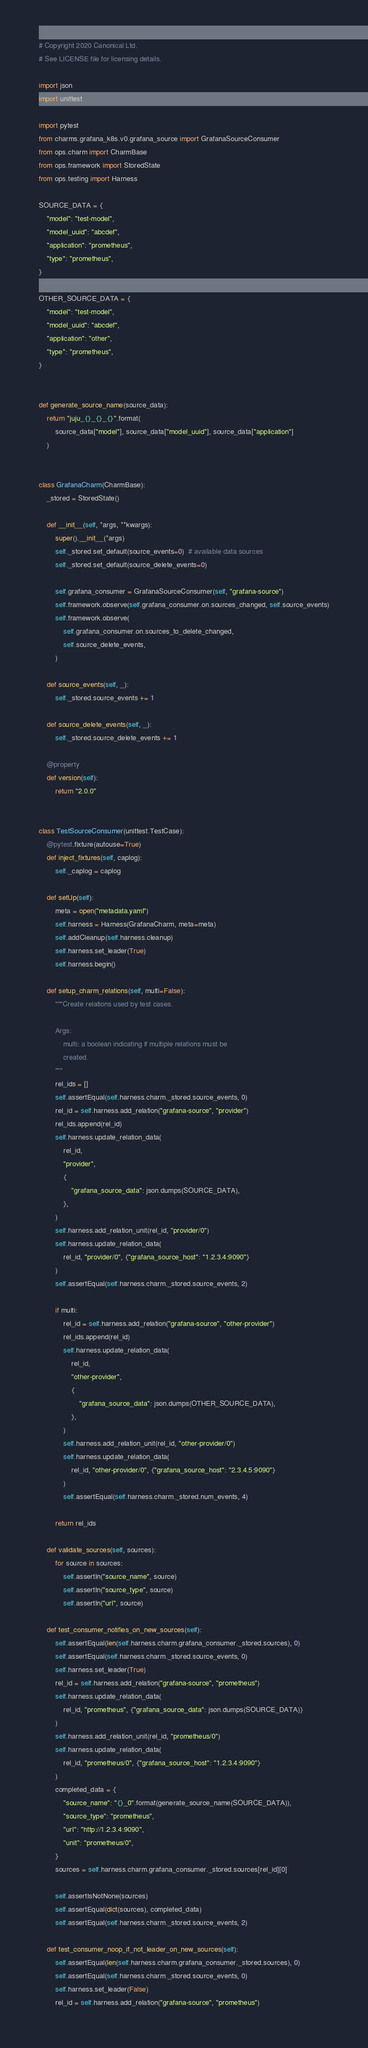<code> <loc_0><loc_0><loc_500><loc_500><_Python_># Copyright 2020 Canonical Ltd.
# See LICENSE file for licensing details.

import json
import unittest

import pytest
from charms.grafana_k8s.v0.grafana_source import GrafanaSourceConsumer
from ops.charm import CharmBase
from ops.framework import StoredState
from ops.testing import Harness

SOURCE_DATA = {
    "model": "test-model",
    "model_uuid": "abcdef",
    "application": "prometheus",
    "type": "prometheus",
}

OTHER_SOURCE_DATA = {
    "model": "test-model",
    "model_uuid": "abcdef",
    "application": "other",
    "type": "prometheus",
}


def generate_source_name(source_data):
    return "juju_{}_{}_{}".format(
        source_data["model"], source_data["model_uuid"], source_data["application"]
    )


class GrafanaCharm(CharmBase):
    _stored = StoredState()

    def __init__(self, *args, **kwargs):
        super().__init__(*args)
        self._stored.set_default(source_events=0)  # available data sources
        self._stored.set_default(source_delete_events=0)

        self.grafana_consumer = GrafanaSourceConsumer(self, "grafana-source")
        self.framework.observe(self.grafana_consumer.on.sources_changed, self.source_events)
        self.framework.observe(
            self.grafana_consumer.on.sources_to_delete_changed,
            self.source_delete_events,
        )

    def source_events(self, _):
        self._stored.source_events += 1

    def source_delete_events(self, _):
        self._stored.source_delete_events += 1

    @property
    def version(self):
        return "2.0.0"


class TestSourceConsumer(unittest.TestCase):
    @pytest.fixture(autouse=True)
    def inject_fixtures(self, caplog):
        self._caplog = caplog

    def setUp(self):
        meta = open("metadata.yaml")
        self.harness = Harness(GrafanaCharm, meta=meta)
        self.addCleanup(self.harness.cleanup)
        self.harness.set_leader(True)
        self.harness.begin()

    def setup_charm_relations(self, multi=False):
        """Create relations used by test cases.

        Args:
            multi: a boolean indicating if multiple relations must be
            created.
        """
        rel_ids = []
        self.assertEqual(self.harness.charm._stored.source_events, 0)
        rel_id = self.harness.add_relation("grafana-source", "provider")
        rel_ids.append(rel_id)
        self.harness.update_relation_data(
            rel_id,
            "provider",
            {
                "grafana_source_data": json.dumps(SOURCE_DATA),
            },
        )
        self.harness.add_relation_unit(rel_id, "provider/0")
        self.harness.update_relation_data(
            rel_id, "provider/0", {"grafana_source_host": "1.2.3.4:9090"}
        )
        self.assertEqual(self.harness.charm._stored.source_events, 2)

        if multi:
            rel_id = self.harness.add_relation("grafana-source", "other-provider")
            rel_ids.append(rel_id)
            self.harness.update_relation_data(
                rel_id,
                "other-provider",
                {
                    "grafana_source_data": json.dumps(OTHER_SOURCE_DATA),
                },
            )
            self.harness.add_relation_unit(rel_id, "other-provider/0")
            self.harness.update_relation_data(
                rel_id, "other-provider/0", {"grafana_source_host": "2.3.4.5:9090"}
            )
            self.assertEqual(self.harness.charm._stored.num_events, 4)

        return rel_ids

    def validate_sources(self, sources):
        for source in sources:
            self.assertIn("source_name", source)
            self.assertIn("source_type", source)
            self.assertIn("url", source)

    def test_consumer_notifies_on_new_sources(self):
        self.assertEqual(len(self.harness.charm.grafana_consumer._stored.sources), 0)
        self.assertEqual(self.harness.charm._stored.source_events, 0)
        self.harness.set_leader(True)
        rel_id = self.harness.add_relation("grafana-source", "prometheus")
        self.harness.update_relation_data(
            rel_id, "prometheus", {"grafana_source_data": json.dumps(SOURCE_DATA)}
        )
        self.harness.add_relation_unit(rel_id, "prometheus/0")
        self.harness.update_relation_data(
            rel_id, "prometheus/0", {"grafana_source_host": "1.2.3.4:9090"}
        )
        completed_data = {
            "source_name": "{}_0".format(generate_source_name(SOURCE_DATA)),
            "source_type": "prometheus",
            "url": "http://1.2.3.4:9090",
            "unit": "prometheus/0",
        }
        sources = self.harness.charm.grafana_consumer._stored.sources[rel_id][0]

        self.assertIsNotNone(sources)
        self.assertEqual(dict(sources), completed_data)
        self.assertEqual(self.harness.charm._stored.source_events, 2)

    def test_consumer_noop_if_not_leader_on_new_sources(self):
        self.assertEqual(len(self.harness.charm.grafana_consumer._stored.sources), 0)
        self.assertEqual(self.harness.charm._stored.source_events, 0)
        self.harness.set_leader(False)
        rel_id = self.harness.add_relation("grafana-source", "prometheus")</code> 